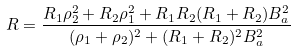Convert formula to latex. <formula><loc_0><loc_0><loc_500><loc_500>R = \frac { R _ { 1 } \rho _ { 2 } ^ { 2 } + R _ { 2 } \rho _ { 1 } ^ { 2 } + R _ { 1 } R _ { 2 } ( R _ { 1 } + R _ { 2 } ) B _ { a } ^ { 2 } } { ( \rho _ { 1 } + \rho _ { 2 } ) ^ { 2 } + ( R _ { 1 } + R _ { 2 } ) ^ { 2 } B _ { a } ^ { 2 } }</formula> 